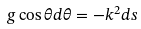<formula> <loc_0><loc_0><loc_500><loc_500>g \cos \theta d \theta = - k ^ { 2 } d s</formula> 